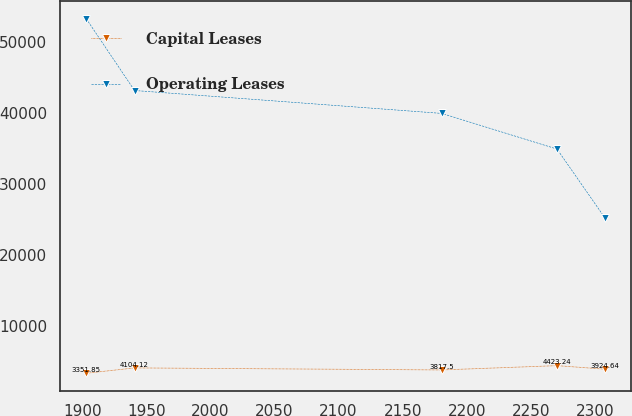Convert chart to OTSL. <chart><loc_0><loc_0><loc_500><loc_500><line_chart><ecel><fcel>Capital Leases<fcel>Operating Leases<nl><fcel>1903.2<fcel>3351.85<fcel>53236<nl><fcel>1940.81<fcel>4104.12<fcel>43147.2<nl><fcel>2180.42<fcel>3817.5<fcel>39924.2<nl><fcel>2270.46<fcel>4423.24<fcel>34903.2<nl><fcel>2308.07<fcel>3924.64<fcel>25147.3<nl></chart> 